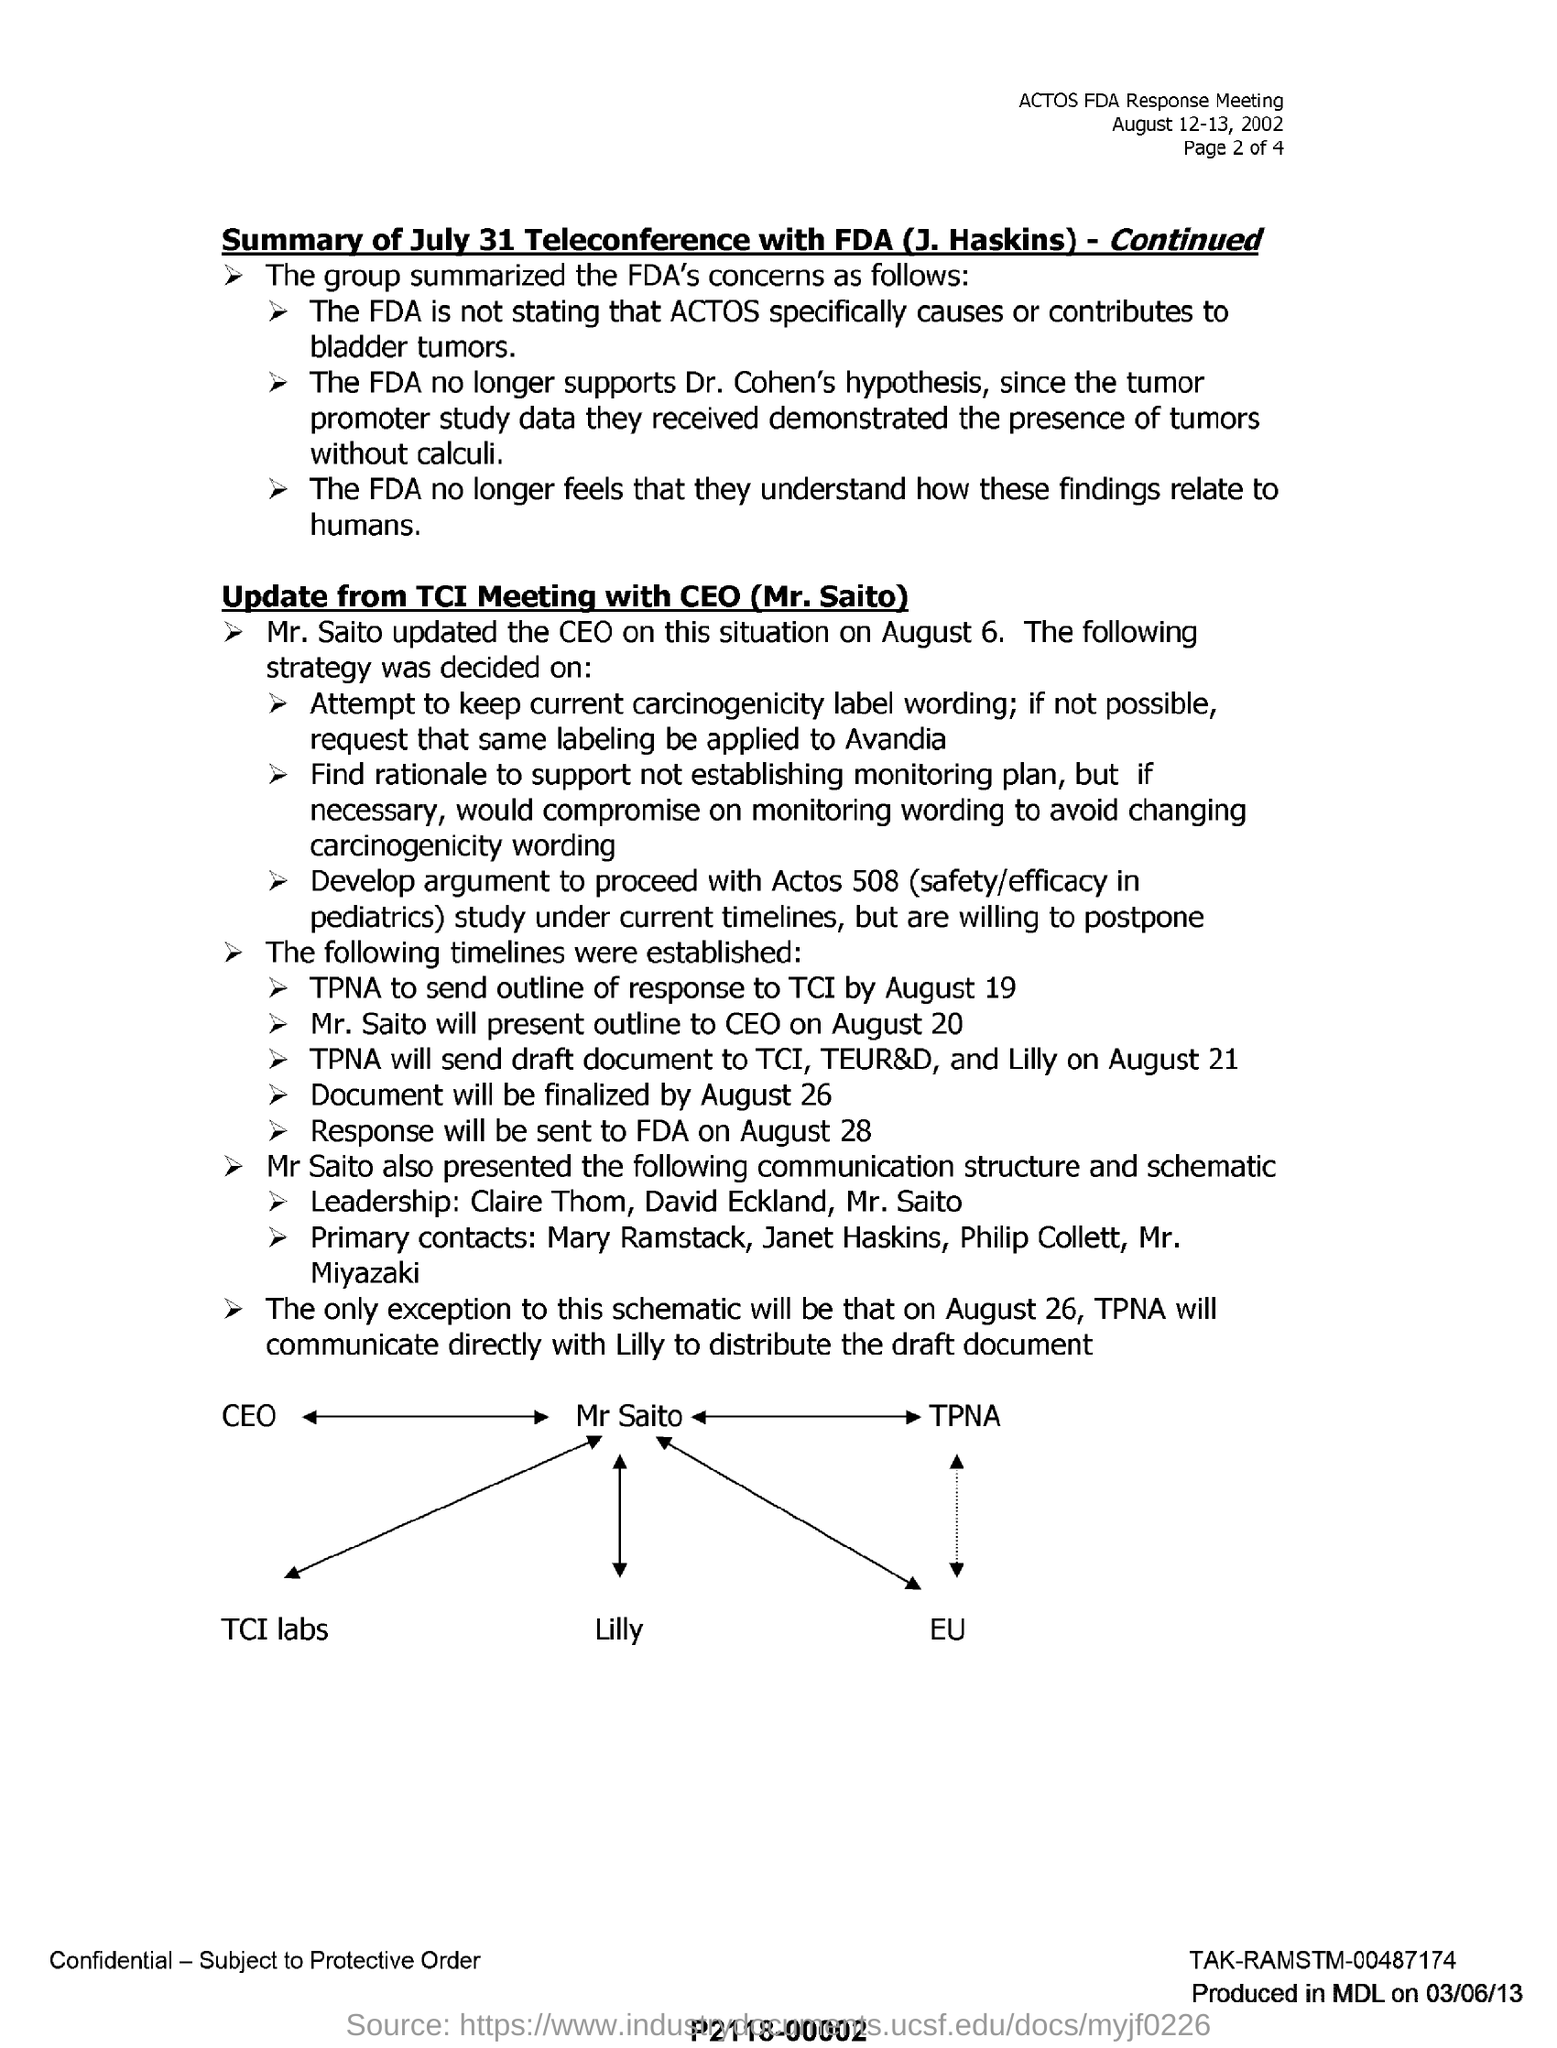Who updated the CEO on August 6?
Provide a succinct answer. Mr. Saito. By when should TPNA send outline of response to TCI ?
Offer a very short reply. By august 19. When will Mr. Saito present outline to CEO?
Provide a short and direct response. August 20. By when will the document be finalized?
Offer a terse response. August 26. 